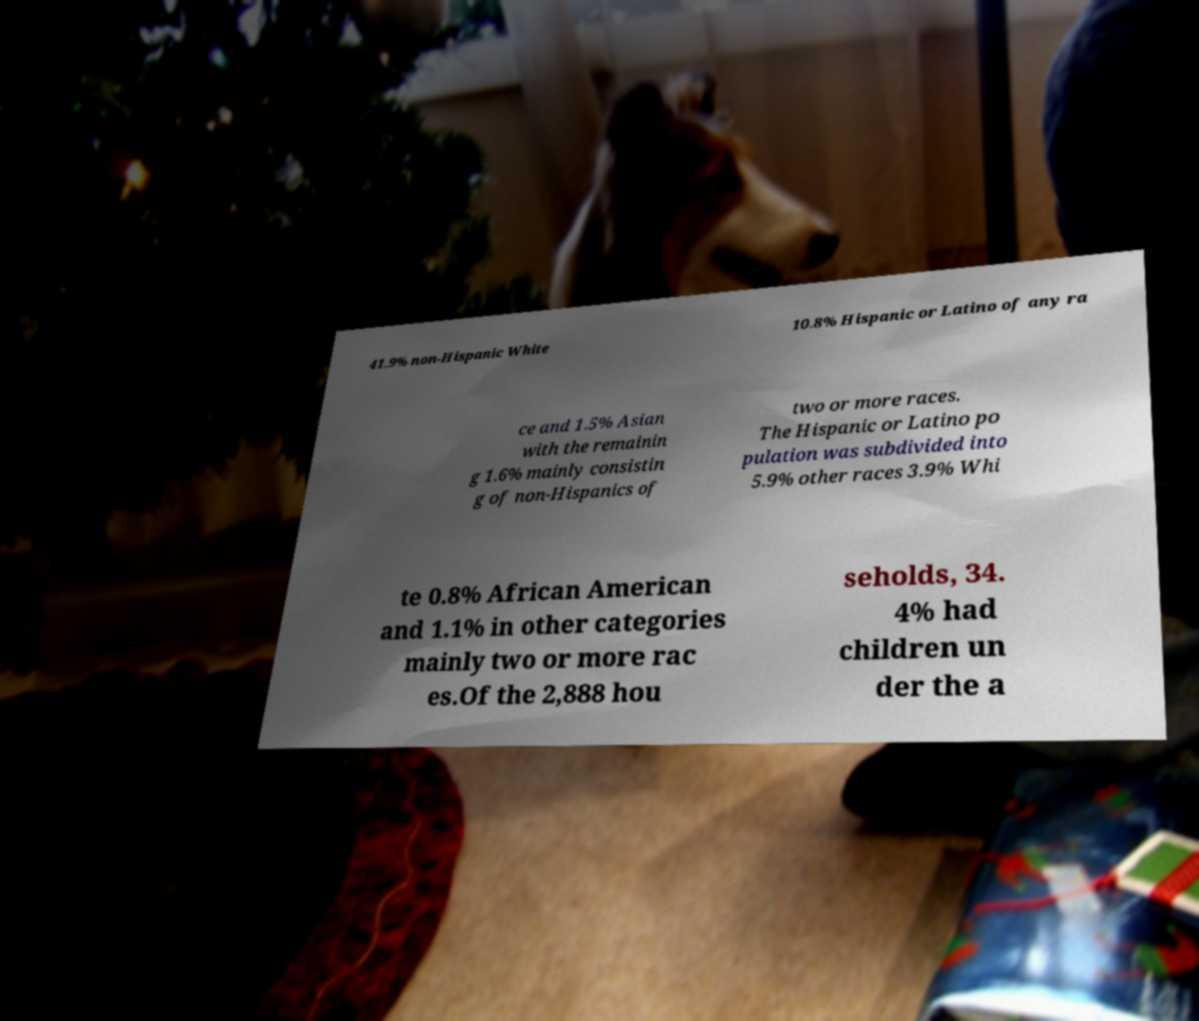What messages or text are displayed in this image? I need them in a readable, typed format. 41.9% non-Hispanic White 10.8% Hispanic or Latino of any ra ce and 1.5% Asian with the remainin g 1.6% mainly consistin g of non-Hispanics of two or more races. The Hispanic or Latino po pulation was subdivided into 5.9% other races 3.9% Whi te 0.8% African American and 1.1% in other categories mainly two or more rac es.Of the 2,888 hou seholds, 34. 4% had children un der the a 